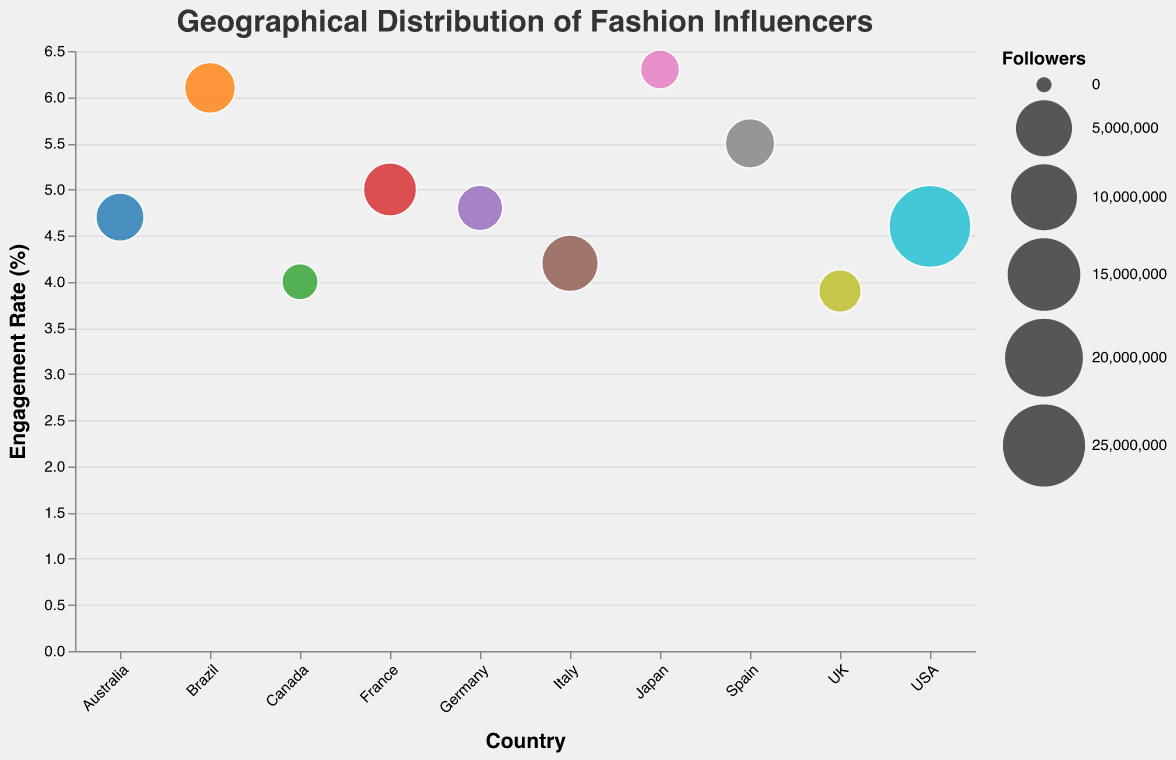What is the engagement rate of the influencer from Japan? The country Japan is represented by Ami Suzuki, and her engagement rate is displayed on the bubble plot.
Answer: 6.3 Which influencer has the highest number of followers? By analyzing the size of the bubbles and the tooltip information, Chiara Ferragni from the USA has the largest bubble, indicating the highest follower count.
Answer: Chiara Ferragni What is the average engagement rate of influencers from Brazil and Spain? The engagement rates for Thássia Naves from Brazil and Aida Domenech from Spain are 6.1 and 5.5, respectively. The average is calculated as (6.1 + 5.5) / 2 = 5.8.
Answer: 5.8 How does the engagement rate of influencers with followers around 3 million compare? Caroline Receveur from France (4 million followers, 5.0%), Thássia Naves from Brazil (3.3 million followers, 6.1%), Aida Domenech from Spain (2.9 million followers, 5.5%) show that engagement rates vary but generally fall between 5.0% and 6.1% for influencers with around 3 million followers.
Answer: Between 5.0% and 6.1% Which country has the influencer with the lowest number of followers, and what is their engagement rate? By looking at the bubble associated with the lowest number of followers, Kayla Seah from Canada has the smallest follower count of 700,000 and an engagement rate of 4.0%.
Answer: Canada, 4.0 Compare the engagement rates of influencers from the USA and the UK? Chiara Ferragni from the USA has an engagement rate of 4.6%, while Zara McDermott from the UK has an engagement rate of 3.9%. This indicates that USA has a higher engagement rate.
Answer: USA has a higher engagement rate What is the total number of followers for influencers from Europe (UK, France, Germany, Italy, Spain)? Summing the followers counts from the listed European countries: UK (1,500,000) + France (4,000,000) + Germany (2,000,000) + Italy (5,200,000) + Spain (2,900,000) = 15,600,000.
Answer: 15,600,000 Which influencer has the highest engagement rate? Using the engagement rate axis, Ami Suzuki from Japan has the highest engagement rate at 6.3%.
Answer: Ami Suzuki What is the difference in engagement rates between the influencers from Australia and Germany? Jessica Stein from Australia has an engagement rate of 4.7%, while Xenia Adonts from Germany has an engagement rate of 4.8%. The difference is 4.8% - 4.7% = 0.1%.
Answer: 0.1% How does the number of followers correlate with engagement rate? Observing the bubble chart, there does not seem to be a clear correlation as high follower counts (like Chiara Ferragni with 25M) do not correlate with the highest engagement rates (Ami Suzuki has highest engagement with 1M followers).
Answer: No clear correlation 